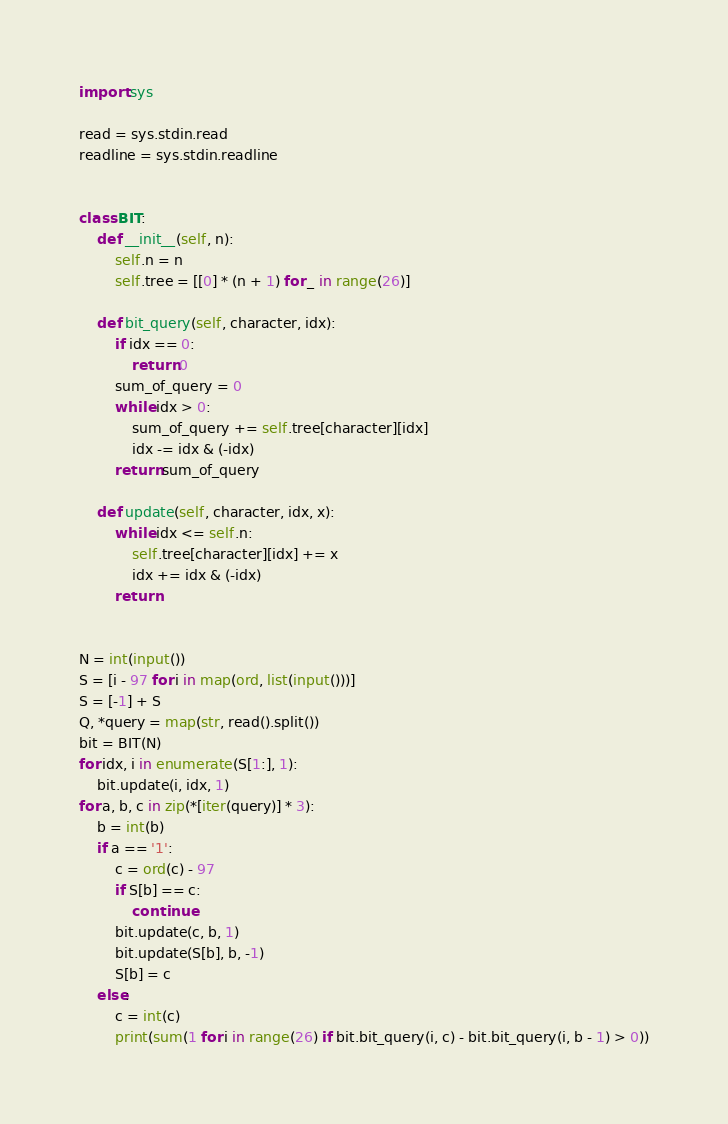Convert code to text. <code><loc_0><loc_0><loc_500><loc_500><_Python_>import sys

read = sys.stdin.read
readline = sys.stdin.readline


class BIT:
    def __init__(self, n):
        self.n = n
        self.tree = [[0] * (n + 1) for _ in range(26)]

    def bit_query(self, character, idx):
        if idx == 0:
            return 0
        sum_of_query = 0
        while idx > 0:
            sum_of_query += self.tree[character][idx]
            idx -= idx & (-idx)
        return sum_of_query

    def update(self, character, idx, x):
        while idx <= self.n:
            self.tree[character][idx] += x
            idx += idx & (-idx)
        return


N = int(input())
S = [i - 97 for i in map(ord, list(input()))]
S = [-1] + S
Q, *query = map(str, read().split())
bit = BIT(N)
for idx, i in enumerate(S[1:], 1):
    bit.update(i, idx, 1)
for a, b, c in zip(*[iter(query)] * 3):
    b = int(b)
    if a == '1':
        c = ord(c) - 97
        if S[b] == c:
            continue
        bit.update(c, b, 1)
        bit.update(S[b], b, -1)
        S[b] = c
    else:
        c = int(c)
        print(sum(1 for i in range(26) if bit.bit_query(i, c) - bit.bit_query(i, b - 1) > 0))
</code> 